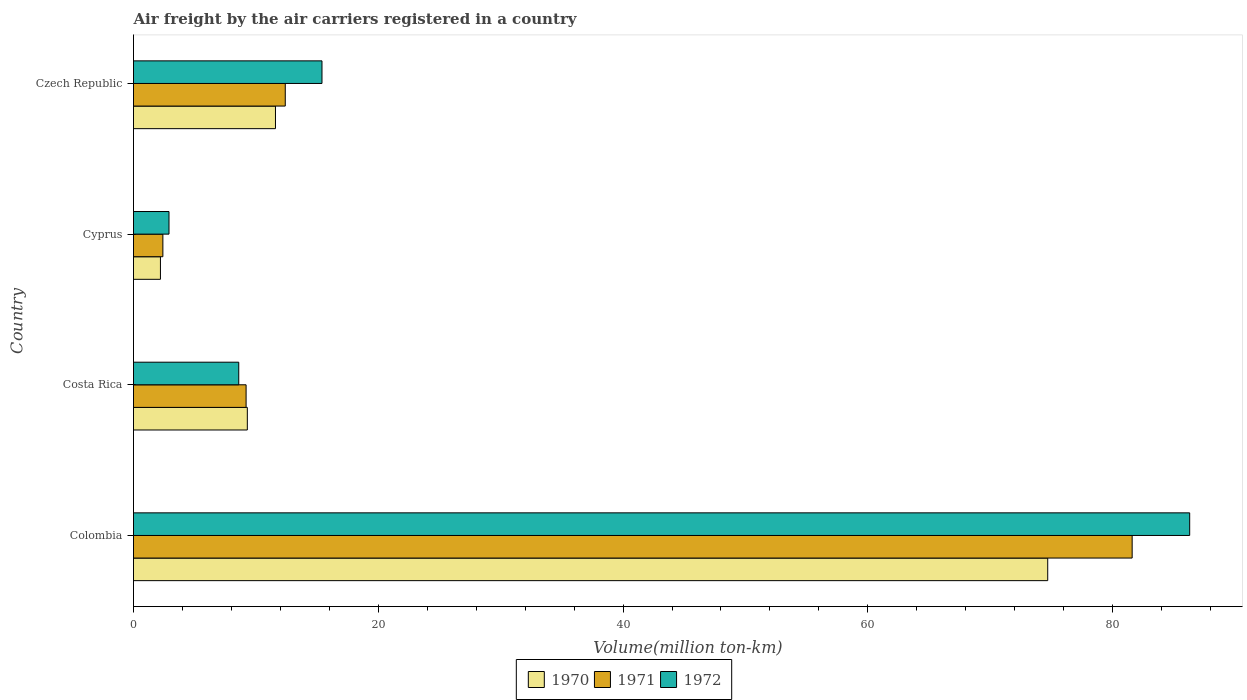How many groups of bars are there?
Keep it short and to the point. 4. Are the number of bars per tick equal to the number of legend labels?
Offer a terse response. Yes. How many bars are there on the 1st tick from the top?
Offer a very short reply. 3. What is the label of the 4th group of bars from the top?
Provide a short and direct response. Colombia. In how many cases, is the number of bars for a given country not equal to the number of legend labels?
Make the answer very short. 0. What is the volume of the air carriers in 1971 in Costa Rica?
Keep it short and to the point. 9.2. Across all countries, what is the maximum volume of the air carriers in 1971?
Offer a very short reply. 81.6. Across all countries, what is the minimum volume of the air carriers in 1971?
Offer a very short reply. 2.4. In which country was the volume of the air carriers in 1972 maximum?
Keep it short and to the point. Colombia. In which country was the volume of the air carriers in 1972 minimum?
Your answer should be compact. Cyprus. What is the total volume of the air carriers in 1972 in the graph?
Offer a very short reply. 113.2. What is the difference between the volume of the air carriers in 1971 in Colombia and that in Costa Rica?
Make the answer very short. 72.4. What is the difference between the volume of the air carriers in 1971 in Czech Republic and the volume of the air carriers in 1970 in Colombia?
Provide a short and direct response. -62.3. What is the average volume of the air carriers in 1972 per country?
Your answer should be very brief. 28.3. What is the difference between the volume of the air carriers in 1971 and volume of the air carriers in 1970 in Cyprus?
Provide a short and direct response. 0.2. What is the ratio of the volume of the air carriers in 1971 in Cyprus to that in Czech Republic?
Your response must be concise. 0.19. Is the difference between the volume of the air carriers in 1971 in Colombia and Cyprus greater than the difference between the volume of the air carriers in 1970 in Colombia and Cyprus?
Your answer should be very brief. Yes. What is the difference between the highest and the second highest volume of the air carriers in 1972?
Offer a very short reply. 70.9. What is the difference between the highest and the lowest volume of the air carriers in 1970?
Your response must be concise. 72.5. Is the sum of the volume of the air carriers in 1972 in Colombia and Czech Republic greater than the maximum volume of the air carriers in 1970 across all countries?
Ensure brevity in your answer.  Yes. What is the difference between two consecutive major ticks on the X-axis?
Provide a short and direct response. 20. Are the values on the major ticks of X-axis written in scientific E-notation?
Provide a short and direct response. No. Does the graph contain grids?
Give a very brief answer. No. How many legend labels are there?
Your answer should be compact. 3. How are the legend labels stacked?
Provide a short and direct response. Horizontal. What is the title of the graph?
Your answer should be very brief. Air freight by the air carriers registered in a country. What is the label or title of the X-axis?
Offer a very short reply. Volume(million ton-km). What is the Volume(million ton-km) of 1970 in Colombia?
Offer a very short reply. 74.7. What is the Volume(million ton-km) in 1971 in Colombia?
Provide a succinct answer. 81.6. What is the Volume(million ton-km) in 1972 in Colombia?
Provide a succinct answer. 86.3. What is the Volume(million ton-km) of 1970 in Costa Rica?
Give a very brief answer. 9.3. What is the Volume(million ton-km) in 1971 in Costa Rica?
Keep it short and to the point. 9.2. What is the Volume(million ton-km) in 1972 in Costa Rica?
Your answer should be very brief. 8.6. What is the Volume(million ton-km) of 1970 in Cyprus?
Make the answer very short. 2.2. What is the Volume(million ton-km) of 1971 in Cyprus?
Offer a terse response. 2.4. What is the Volume(million ton-km) of 1972 in Cyprus?
Provide a short and direct response. 2.9. What is the Volume(million ton-km) of 1970 in Czech Republic?
Your response must be concise. 11.6. What is the Volume(million ton-km) of 1971 in Czech Republic?
Offer a very short reply. 12.4. What is the Volume(million ton-km) of 1972 in Czech Republic?
Make the answer very short. 15.4. Across all countries, what is the maximum Volume(million ton-km) of 1970?
Provide a short and direct response. 74.7. Across all countries, what is the maximum Volume(million ton-km) in 1971?
Your answer should be very brief. 81.6. Across all countries, what is the maximum Volume(million ton-km) in 1972?
Your response must be concise. 86.3. Across all countries, what is the minimum Volume(million ton-km) of 1970?
Your response must be concise. 2.2. Across all countries, what is the minimum Volume(million ton-km) of 1971?
Offer a terse response. 2.4. Across all countries, what is the minimum Volume(million ton-km) in 1972?
Ensure brevity in your answer.  2.9. What is the total Volume(million ton-km) of 1970 in the graph?
Provide a short and direct response. 97.8. What is the total Volume(million ton-km) of 1971 in the graph?
Your response must be concise. 105.6. What is the total Volume(million ton-km) of 1972 in the graph?
Ensure brevity in your answer.  113.2. What is the difference between the Volume(million ton-km) of 1970 in Colombia and that in Costa Rica?
Offer a very short reply. 65.4. What is the difference between the Volume(million ton-km) of 1971 in Colombia and that in Costa Rica?
Your response must be concise. 72.4. What is the difference between the Volume(million ton-km) in 1972 in Colombia and that in Costa Rica?
Offer a very short reply. 77.7. What is the difference between the Volume(million ton-km) in 1970 in Colombia and that in Cyprus?
Make the answer very short. 72.5. What is the difference between the Volume(million ton-km) of 1971 in Colombia and that in Cyprus?
Provide a short and direct response. 79.2. What is the difference between the Volume(million ton-km) of 1972 in Colombia and that in Cyprus?
Your response must be concise. 83.4. What is the difference between the Volume(million ton-km) of 1970 in Colombia and that in Czech Republic?
Your answer should be compact. 63.1. What is the difference between the Volume(million ton-km) in 1971 in Colombia and that in Czech Republic?
Provide a short and direct response. 69.2. What is the difference between the Volume(million ton-km) in 1972 in Colombia and that in Czech Republic?
Offer a terse response. 70.9. What is the difference between the Volume(million ton-km) of 1970 in Costa Rica and that in Cyprus?
Your answer should be compact. 7.1. What is the difference between the Volume(million ton-km) in 1972 in Costa Rica and that in Cyprus?
Provide a short and direct response. 5.7. What is the difference between the Volume(million ton-km) of 1970 in Costa Rica and that in Czech Republic?
Provide a short and direct response. -2.3. What is the difference between the Volume(million ton-km) of 1971 in Costa Rica and that in Czech Republic?
Keep it short and to the point. -3.2. What is the difference between the Volume(million ton-km) in 1971 in Cyprus and that in Czech Republic?
Your answer should be very brief. -10. What is the difference between the Volume(million ton-km) of 1970 in Colombia and the Volume(million ton-km) of 1971 in Costa Rica?
Give a very brief answer. 65.5. What is the difference between the Volume(million ton-km) in 1970 in Colombia and the Volume(million ton-km) in 1972 in Costa Rica?
Offer a terse response. 66.1. What is the difference between the Volume(million ton-km) in 1971 in Colombia and the Volume(million ton-km) in 1972 in Costa Rica?
Your response must be concise. 73. What is the difference between the Volume(million ton-km) of 1970 in Colombia and the Volume(million ton-km) of 1971 in Cyprus?
Your response must be concise. 72.3. What is the difference between the Volume(million ton-km) in 1970 in Colombia and the Volume(million ton-km) in 1972 in Cyprus?
Ensure brevity in your answer.  71.8. What is the difference between the Volume(million ton-km) of 1971 in Colombia and the Volume(million ton-km) of 1972 in Cyprus?
Provide a short and direct response. 78.7. What is the difference between the Volume(million ton-km) of 1970 in Colombia and the Volume(million ton-km) of 1971 in Czech Republic?
Your answer should be very brief. 62.3. What is the difference between the Volume(million ton-km) of 1970 in Colombia and the Volume(million ton-km) of 1972 in Czech Republic?
Your answer should be compact. 59.3. What is the difference between the Volume(million ton-km) of 1971 in Colombia and the Volume(million ton-km) of 1972 in Czech Republic?
Keep it short and to the point. 66.2. What is the difference between the Volume(million ton-km) in 1970 in Cyprus and the Volume(million ton-km) in 1971 in Czech Republic?
Offer a very short reply. -10.2. What is the average Volume(million ton-km) in 1970 per country?
Offer a very short reply. 24.45. What is the average Volume(million ton-km) of 1971 per country?
Give a very brief answer. 26.4. What is the average Volume(million ton-km) in 1972 per country?
Your answer should be very brief. 28.3. What is the difference between the Volume(million ton-km) of 1971 and Volume(million ton-km) of 1972 in Colombia?
Your answer should be very brief. -4.7. What is the difference between the Volume(million ton-km) in 1970 and Volume(million ton-km) in 1971 in Costa Rica?
Provide a short and direct response. 0.1. What is the difference between the Volume(million ton-km) of 1970 and Volume(million ton-km) of 1971 in Cyprus?
Offer a very short reply. -0.2. What is the difference between the Volume(million ton-km) in 1970 and Volume(million ton-km) in 1972 in Czech Republic?
Your answer should be very brief. -3.8. What is the difference between the Volume(million ton-km) of 1971 and Volume(million ton-km) of 1972 in Czech Republic?
Make the answer very short. -3. What is the ratio of the Volume(million ton-km) in 1970 in Colombia to that in Costa Rica?
Make the answer very short. 8.03. What is the ratio of the Volume(million ton-km) of 1971 in Colombia to that in Costa Rica?
Provide a short and direct response. 8.87. What is the ratio of the Volume(million ton-km) in 1972 in Colombia to that in Costa Rica?
Give a very brief answer. 10.03. What is the ratio of the Volume(million ton-km) in 1970 in Colombia to that in Cyprus?
Provide a short and direct response. 33.95. What is the ratio of the Volume(million ton-km) in 1971 in Colombia to that in Cyprus?
Offer a terse response. 34. What is the ratio of the Volume(million ton-km) in 1972 in Colombia to that in Cyprus?
Make the answer very short. 29.76. What is the ratio of the Volume(million ton-km) in 1970 in Colombia to that in Czech Republic?
Your answer should be compact. 6.44. What is the ratio of the Volume(million ton-km) in 1971 in Colombia to that in Czech Republic?
Give a very brief answer. 6.58. What is the ratio of the Volume(million ton-km) of 1972 in Colombia to that in Czech Republic?
Ensure brevity in your answer.  5.6. What is the ratio of the Volume(million ton-km) of 1970 in Costa Rica to that in Cyprus?
Provide a short and direct response. 4.23. What is the ratio of the Volume(million ton-km) of 1971 in Costa Rica to that in Cyprus?
Your answer should be very brief. 3.83. What is the ratio of the Volume(million ton-km) in 1972 in Costa Rica to that in Cyprus?
Make the answer very short. 2.97. What is the ratio of the Volume(million ton-km) of 1970 in Costa Rica to that in Czech Republic?
Keep it short and to the point. 0.8. What is the ratio of the Volume(million ton-km) of 1971 in Costa Rica to that in Czech Republic?
Ensure brevity in your answer.  0.74. What is the ratio of the Volume(million ton-km) in 1972 in Costa Rica to that in Czech Republic?
Your answer should be compact. 0.56. What is the ratio of the Volume(million ton-km) in 1970 in Cyprus to that in Czech Republic?
Offer a very short reply. 0.19. What is the ratio of the Volume(million ton-km) in 1971 in Cyprus to that in Czech Republic?
Offer a very short reply. 0.19. What is the ratio of the Volume(million ton-km) of 1972 in Cyprus to that in Czech Republic?
Your answer should be very brief. 0.19. What is the difference between the highest and the second highest Volume(million ton-km) in 1970?
Your answer should be compact. 63.1. What is the difference between the highest and the second highest Volume(million ton-km) of 1971?
Ensure brevity in your answer.  69.2. What is the difference between the highest and the second highest Volume(million ton-km) of 1972?
Offer a very short reply. 70.9. What is the difference between the highest and the lowest Volume(million ton-km) of 1970?
Offer a terse response. 72.5. What is the difference between the highest and the lowest Volume(million ton-km) in 1971?
Your answer should be very brief. 79.2. What is the difference between the highest and the lowest Volume(million ton-km) of 1972?
Ensure brevity in your answer.  83.4. 